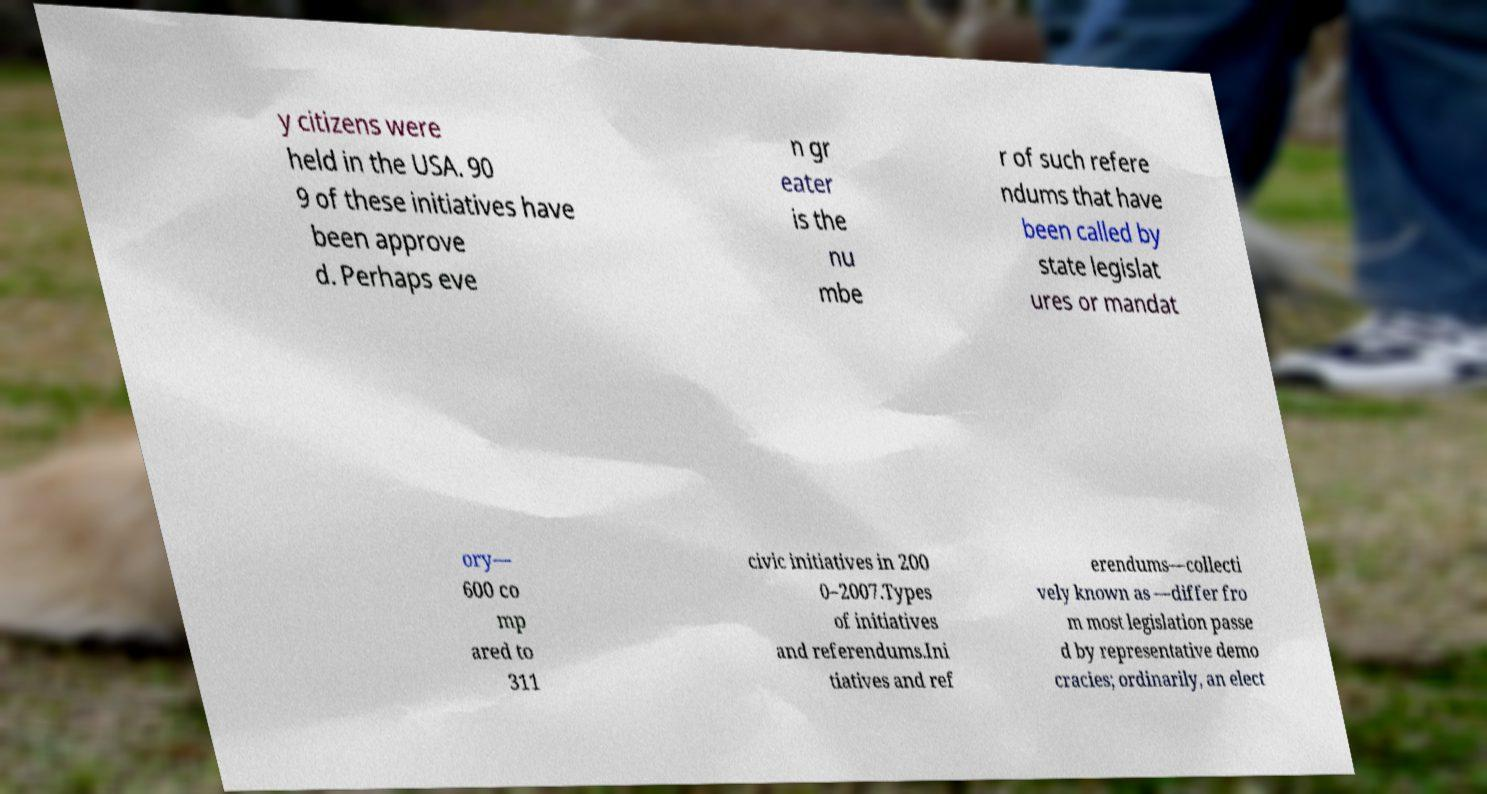Can you accurately transcribe the text from the provided image for me? y citizens were held in the USA. 90 9 of these initiatives have been approve d. Perhaps eve n gr eater is the nu mbe r of such refere ndums that have been called by state legislat ures or mandat ory— 600 co mp ared to 311 civic initiatives in 200 0–2007.Types of initiatives and referendums.Ini tiatives and ref erendums—collecti vely known as —differ fro m most legislation passe d by representative demo cracies; ordinarily, an elect 